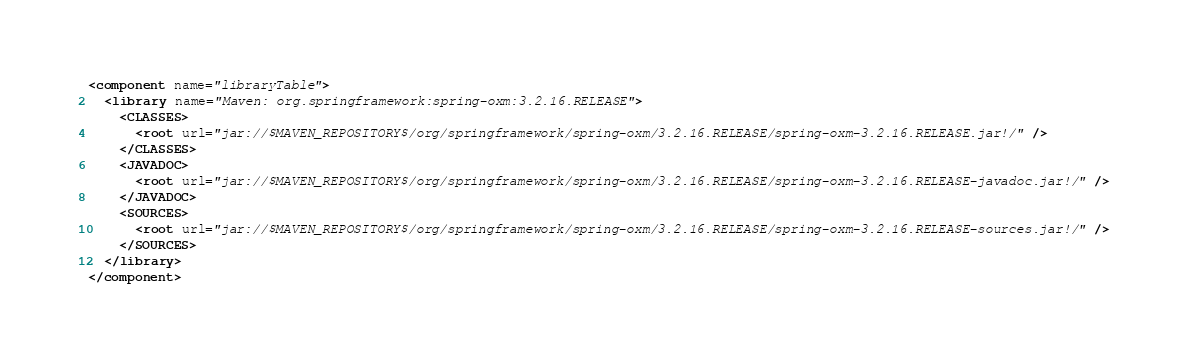Convert code to text. <code><loc_0><loc_0><loc_500><loc_500><_XML_><component name="libraryTable">
  <library name="Maven: org.springframework:spring-oxm:3.2.16.RELEASE">
    <CLASSES>
      <root url="jar://$MAVEN_REPOSITORY$/org/springframework/spring-oxm/3.2.16.RELEASE/spring-oxm-3.2.16.RELEASE.jar!/" />
    </CLASSES>
    <JAVADOC>
      <root url="jar://$MAVEN_REPOSITORY$/org/springframework/spring-oxm/3.2.16.RELEASE/spring-oxm-3.2.16.RELEASE-javadoc.jar!/" />
    </JAVADOC>
    <SOURCES>
      <root url="jar://$MAVEN_REPOSITORY$/org/springframework/spring-oxm/3.2.16.RELEASE/spring-oxm-3.2.16.RELEASE-sources.jar!/" />
    </SOURCES>
  </library>
</component></code> 